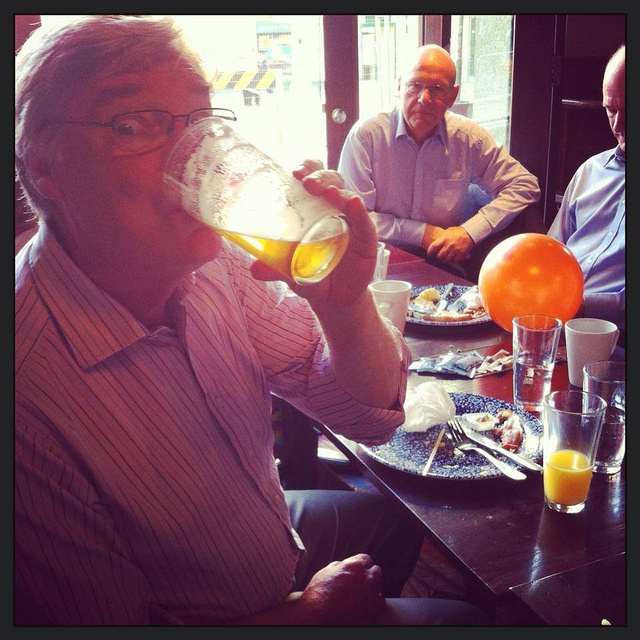Describe the objects in this image and their specific colors. I can see people in black, purple, and brown tones, dining table in black and purple tones, people in black, purple, gray, and tan tones, cup in black, ivory, brown, and tan tones, and people in black, lightgray, purple, and darkgray tones in this image. 